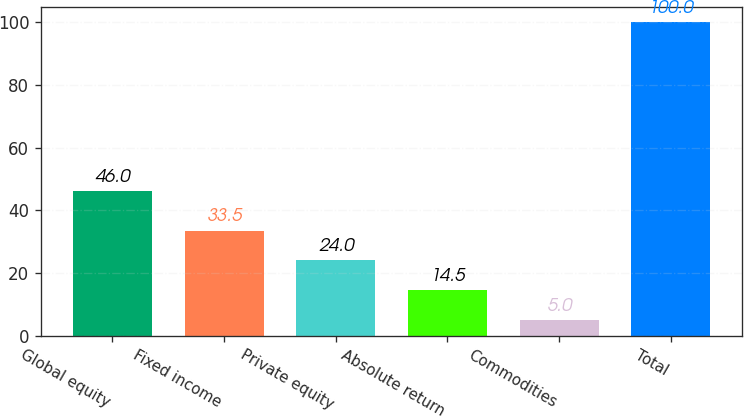Convert chart to OTSL. <chart><loc_0><loc_0><loc_500><loc_500><bar_chart><fcel>Global equity<fcel>Fixed income<fcel>Private equity<fcel>Absolute return<fcel>Commodities<fcel>Total<nl><fcel>46<fcel>33.5<fcel>24<fcel>14.5<fcel>5<fcel>100<nl></chart> 